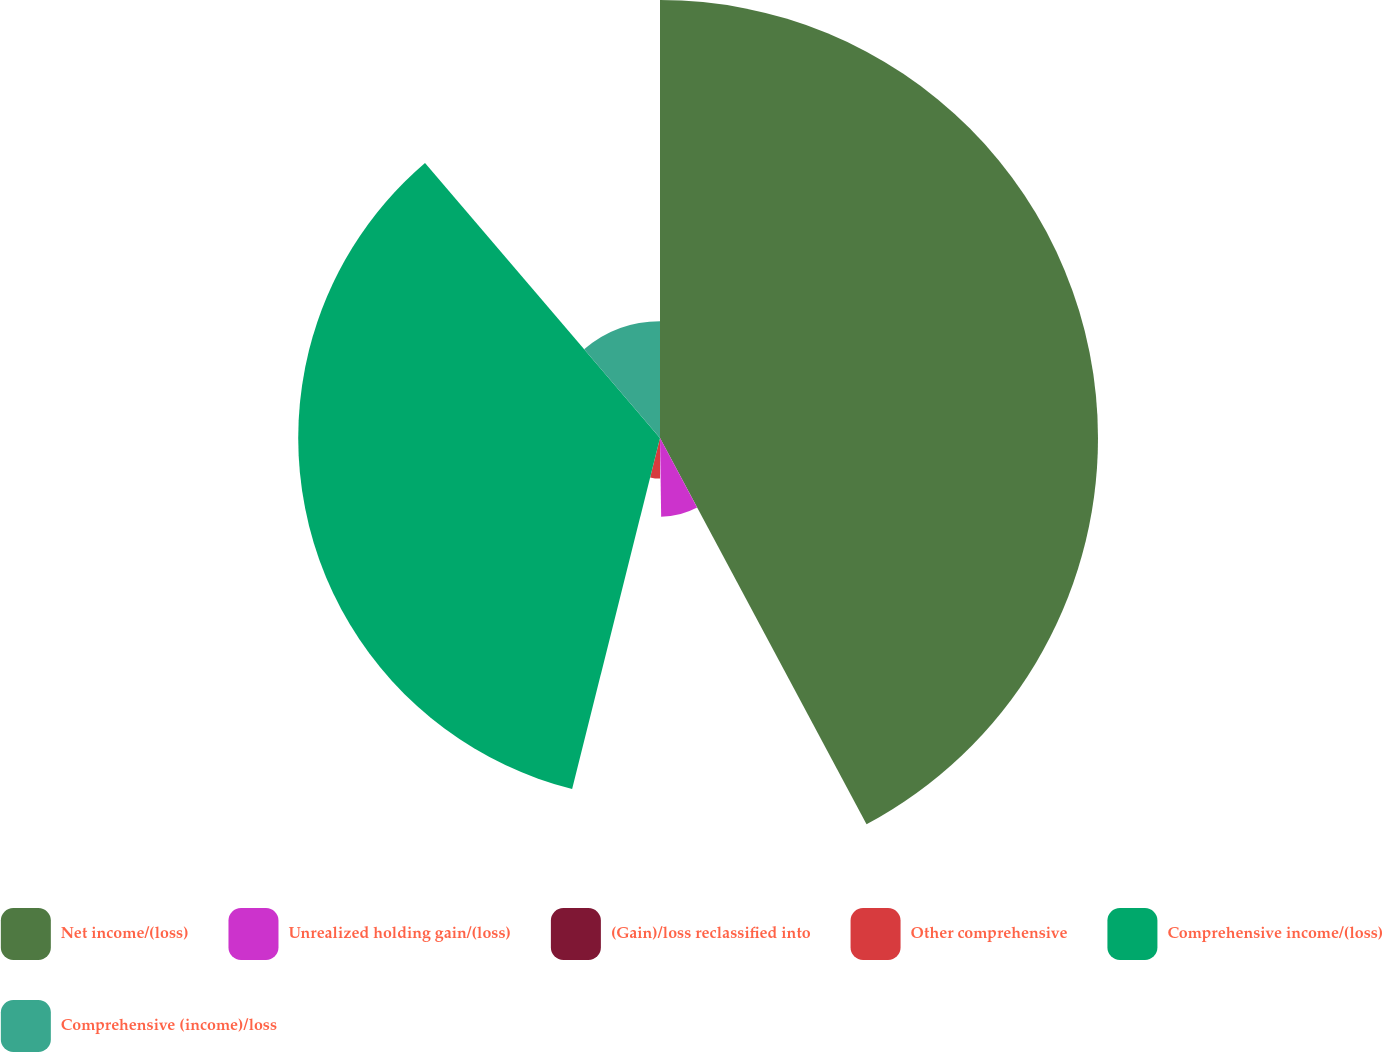Convert chart. <chart><loc_0><loc_0><loc_500><loc_500><pie_chart><fcel>Net income/(loss)<fcel>Unrealized holding gain/(loss)<fcel>(Gain)/loss reclassified into<fcel>Other comprehensive<fcel>Comprehensive income/(loss)<fcel>Comprehensive (income)/loss<nl><fcel>42.18%<fcel>7.58%<fcel>0.23%<fcel>3.91%<fcel>34.84%<fcel>11.25%<nl></chart> 